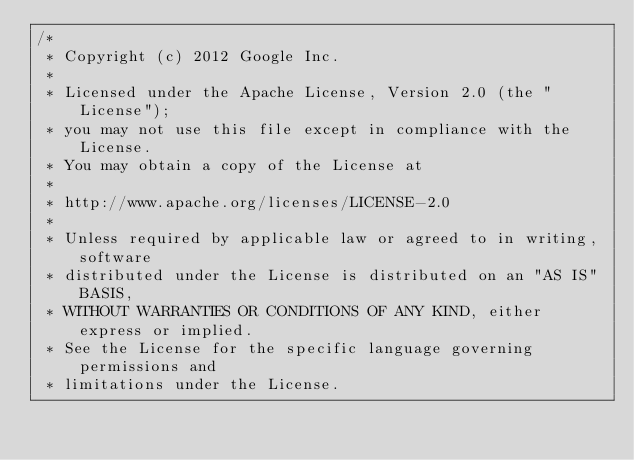Convert code to text. <code><loc_0><loc_0><loc_500><loc_500><_Java_>/*
 * Copyright (c) 2012 Google Inc.
 *
 * Licensed under the Apache License, Version 2.0 (the "License");
 * you may not use this file except in compliance with the License.
 * You may obtain a copy of the License at
 *
 * http://www.apache.org/licenses/LICENSE-2.0
 *
 * Unless required by applicable law or agreed to in writing, software
 * distributed under the License is distributed on an "AS IS" BASIS,
 * WITHOUT WARRANTIES OR CONDITIONS OF ANY KIND, either express or implied.
 * See the License for the specific language governing permissions and
 * limitations under the License.</code> 